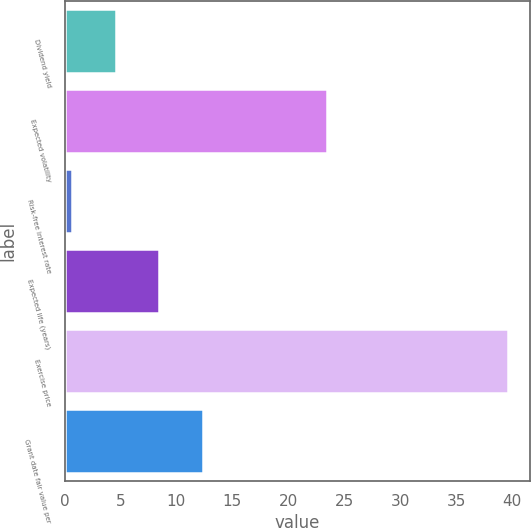Convert chart to OTSL. <chart><loc_0><loc_0><loc_500><loc_500><bar_chart><fcel>Dividend yield<fcel>Expected volatility<fcel>Risk-free interest rate<fcel>Expected life (years)<fcel>Exercise price<fcel>Grant date fair value per<nl><fcel>4.59<fcel>23.5<fcel>0.7<fcel>8.48<fcel>39.6<fcel>12.37<nl></chart> 